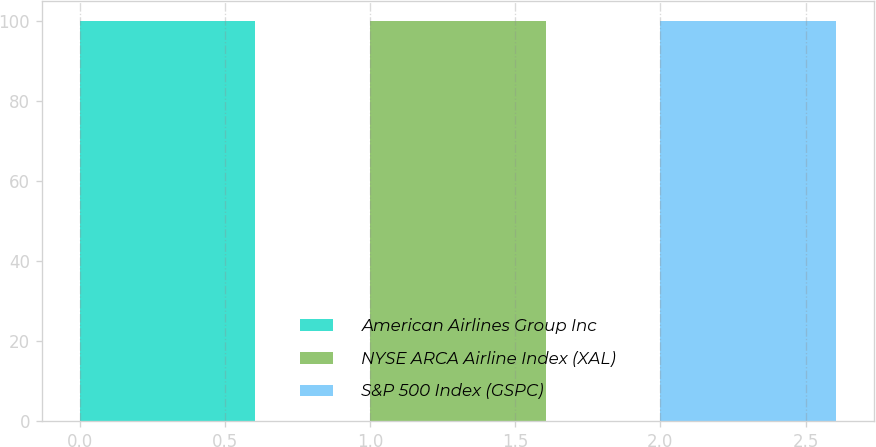Convert chart. <chart><loc_0><loc_0><loc_500><loc_500><bar_chart><fcel>American Airlines Group Inc<fcel>NYSE ARCA Airline Index (XAL)<fcel>S&P 500 Index (GSPC)<nl><fcel>100<fcel>100.1<fcel>100.2<nl></chart> 